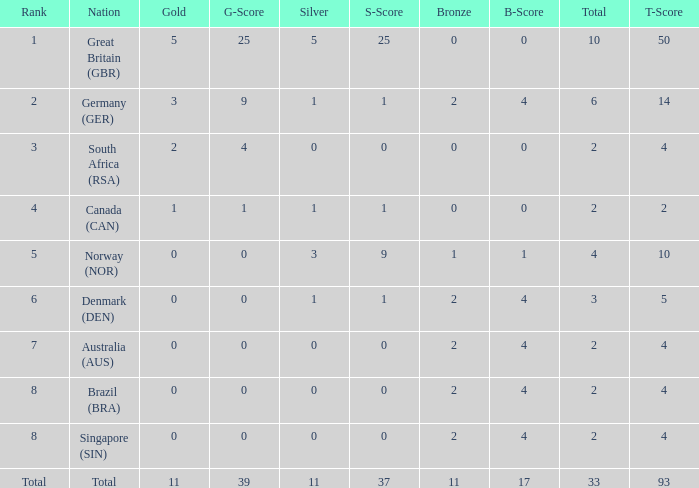What is bronze when the rank is 3 and the total is more than 2? None. Would you be able to parse every entry in this table? {'header': ['Rank', 'Nation', 'Gold', 'G-Score', 'Silver', 'S-Score', 'Bronze', 'B-Score', 'Total', 'T-Score'], 'rows': [['1', 'Great Britain (GBR)', '5', '25', '5', '25', '0', '0', '10', '50'], ['2', 'Germany (GER)', '3', '9', '1', '1', '2', '4', '6', '14'], ['3', 'South Africa (RSA)', '2', '4', '0', '0', '0', '0', '2', '4'], ['4', 'Canada (CAN)', '1', '1', '1', '1', '0', '0', '2', '2'], ['5', 'Norway (NOR)', '0', '0', '3', '9', '1', '1', '4', '10'], ['6', 'Denmark (DEN)', '0', '0', '1', '1', '2', '4', '3', '5'], ['7', 'Australia (AUS)', '0', '0', '0', '0', '2', '4', '2', '4'], ['8', 'Brazil (BRA)', '0', '0', '0', '0', '2', '4', '2', '4'], ['8', 'Singapore (SIN)', '0', '0', '0', '0', '2', '4', '2', '4'], ['Total', 'Total', '11', '39', '11', '37', '11', '17', '33', '93']]} 